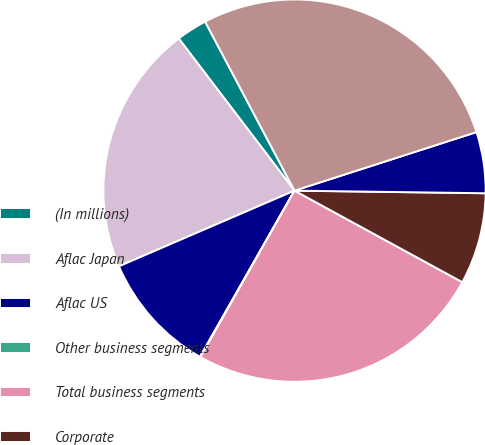Convert chart to OTSL. <chart><loc_0><loc_0><loc_500><loc_500><pie_chart><fcel>(In millions)<fcel>Aflac Japan<fcel>Aflac US<fcel>Other business segments<fcel>Total business segments<fcel>Corporate<fcel>Intercompany eliminations<fcel>Total assets<nl><fcel>2.61%<fcel>21.12%<fcel>10.29%<fcel>0.05%<fcel>25.23%<fcel>7.73%<fcel>5.17%<fcel>27.79%<nl></chart> 